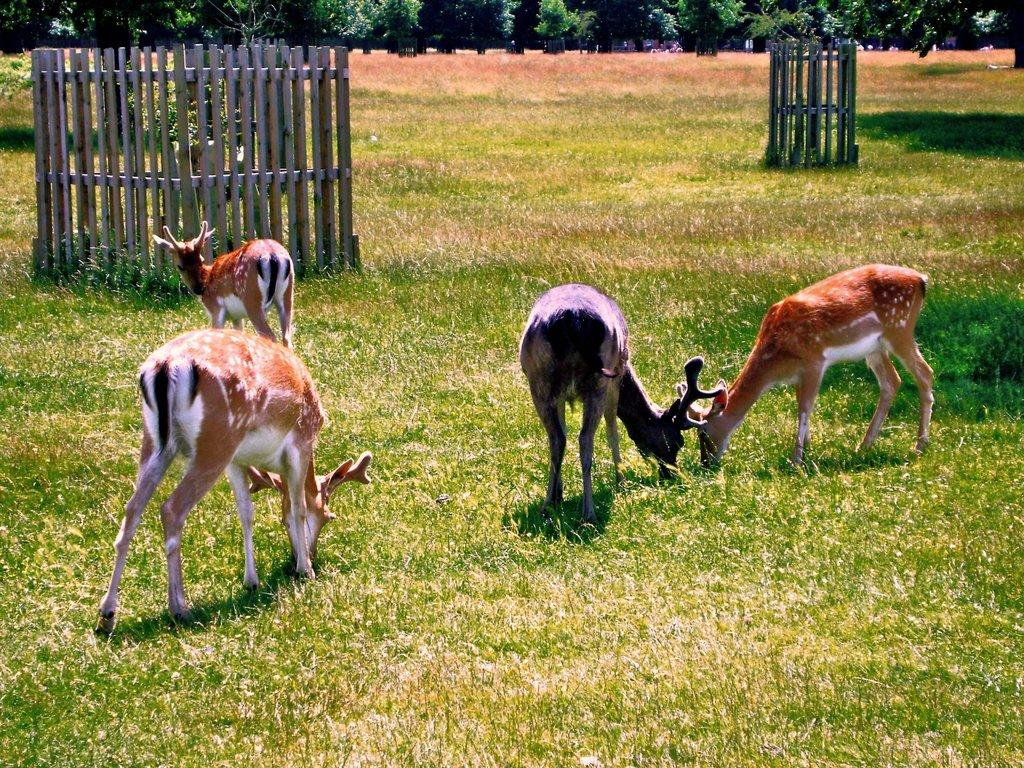What types of living organisms can be seen in the image? There are animals in the image. What can be seen in the background of the image? There are fences and trees in the background of the image. What is visible at the bottom of the image? The ground is visible at the bottom of the image. What type of vegetation covers the ground in the image? The ground is covered with grass. What type of slope can be seen in the image? There is no slope present in the image. 